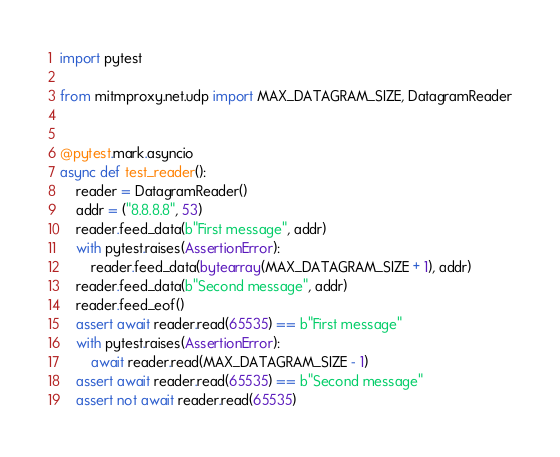Convert code to text. <code><loc_0><loc_0><loc_500><loc_500><_Python_>import pytest

from mitmproxy.net.udp import MAX_DATAGRAM_SIZE, DatagramReader


@pytest.mark.asyncio
async def test_reader():
    reader = DatagramReader()
    addr = ("8.8.8.8", 53)
    reader.feed_data(b"First message", addr)
    with pytest.raises(AssertionError):
        reader.feed_data(bytearray(MAX_DATAGRAM_SIZE + 1), addr)
    reader.feed_data(b"Second message", addr)
    reader.feed_eof()
    assert await reader.read(65535) == b"First message"
    with pytest.raises(AssertionError):
        await reader.read(MAX_DATAGRAM_SIZE - 1)
    assert await reader.read(65535) == b"Second message"
    assert not await reader.read(65535)
</code> 